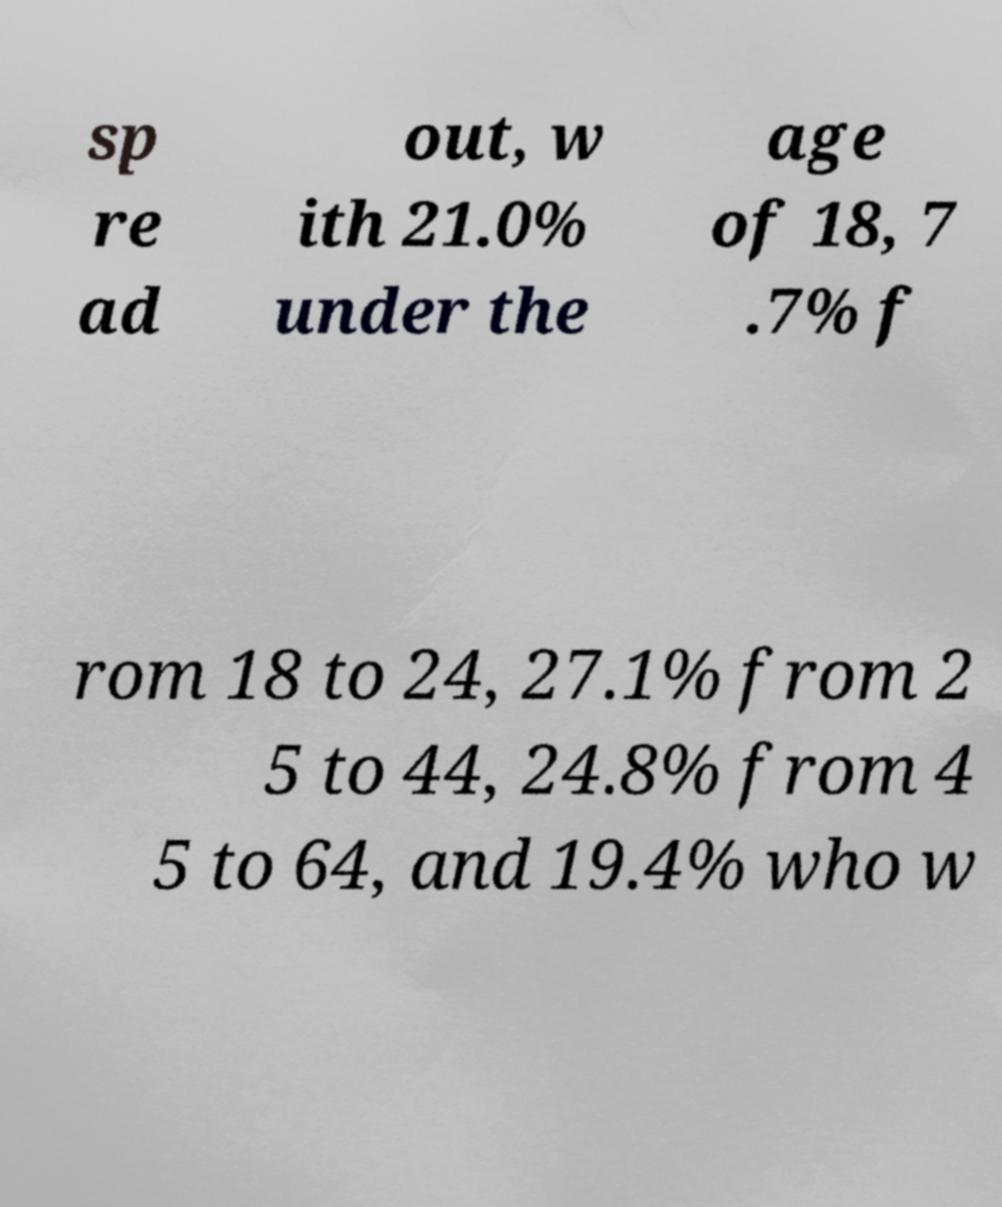There's text embedded in this image that I need extracted. Can you transcribe it verbatim? sp re ad out, w ith 21.0% under the age of 18, 7 .7% f rom 18 to 24, 27.1% from 2 5 to 44, 24.8% from 4 5 to 64, and 19.4% who w 